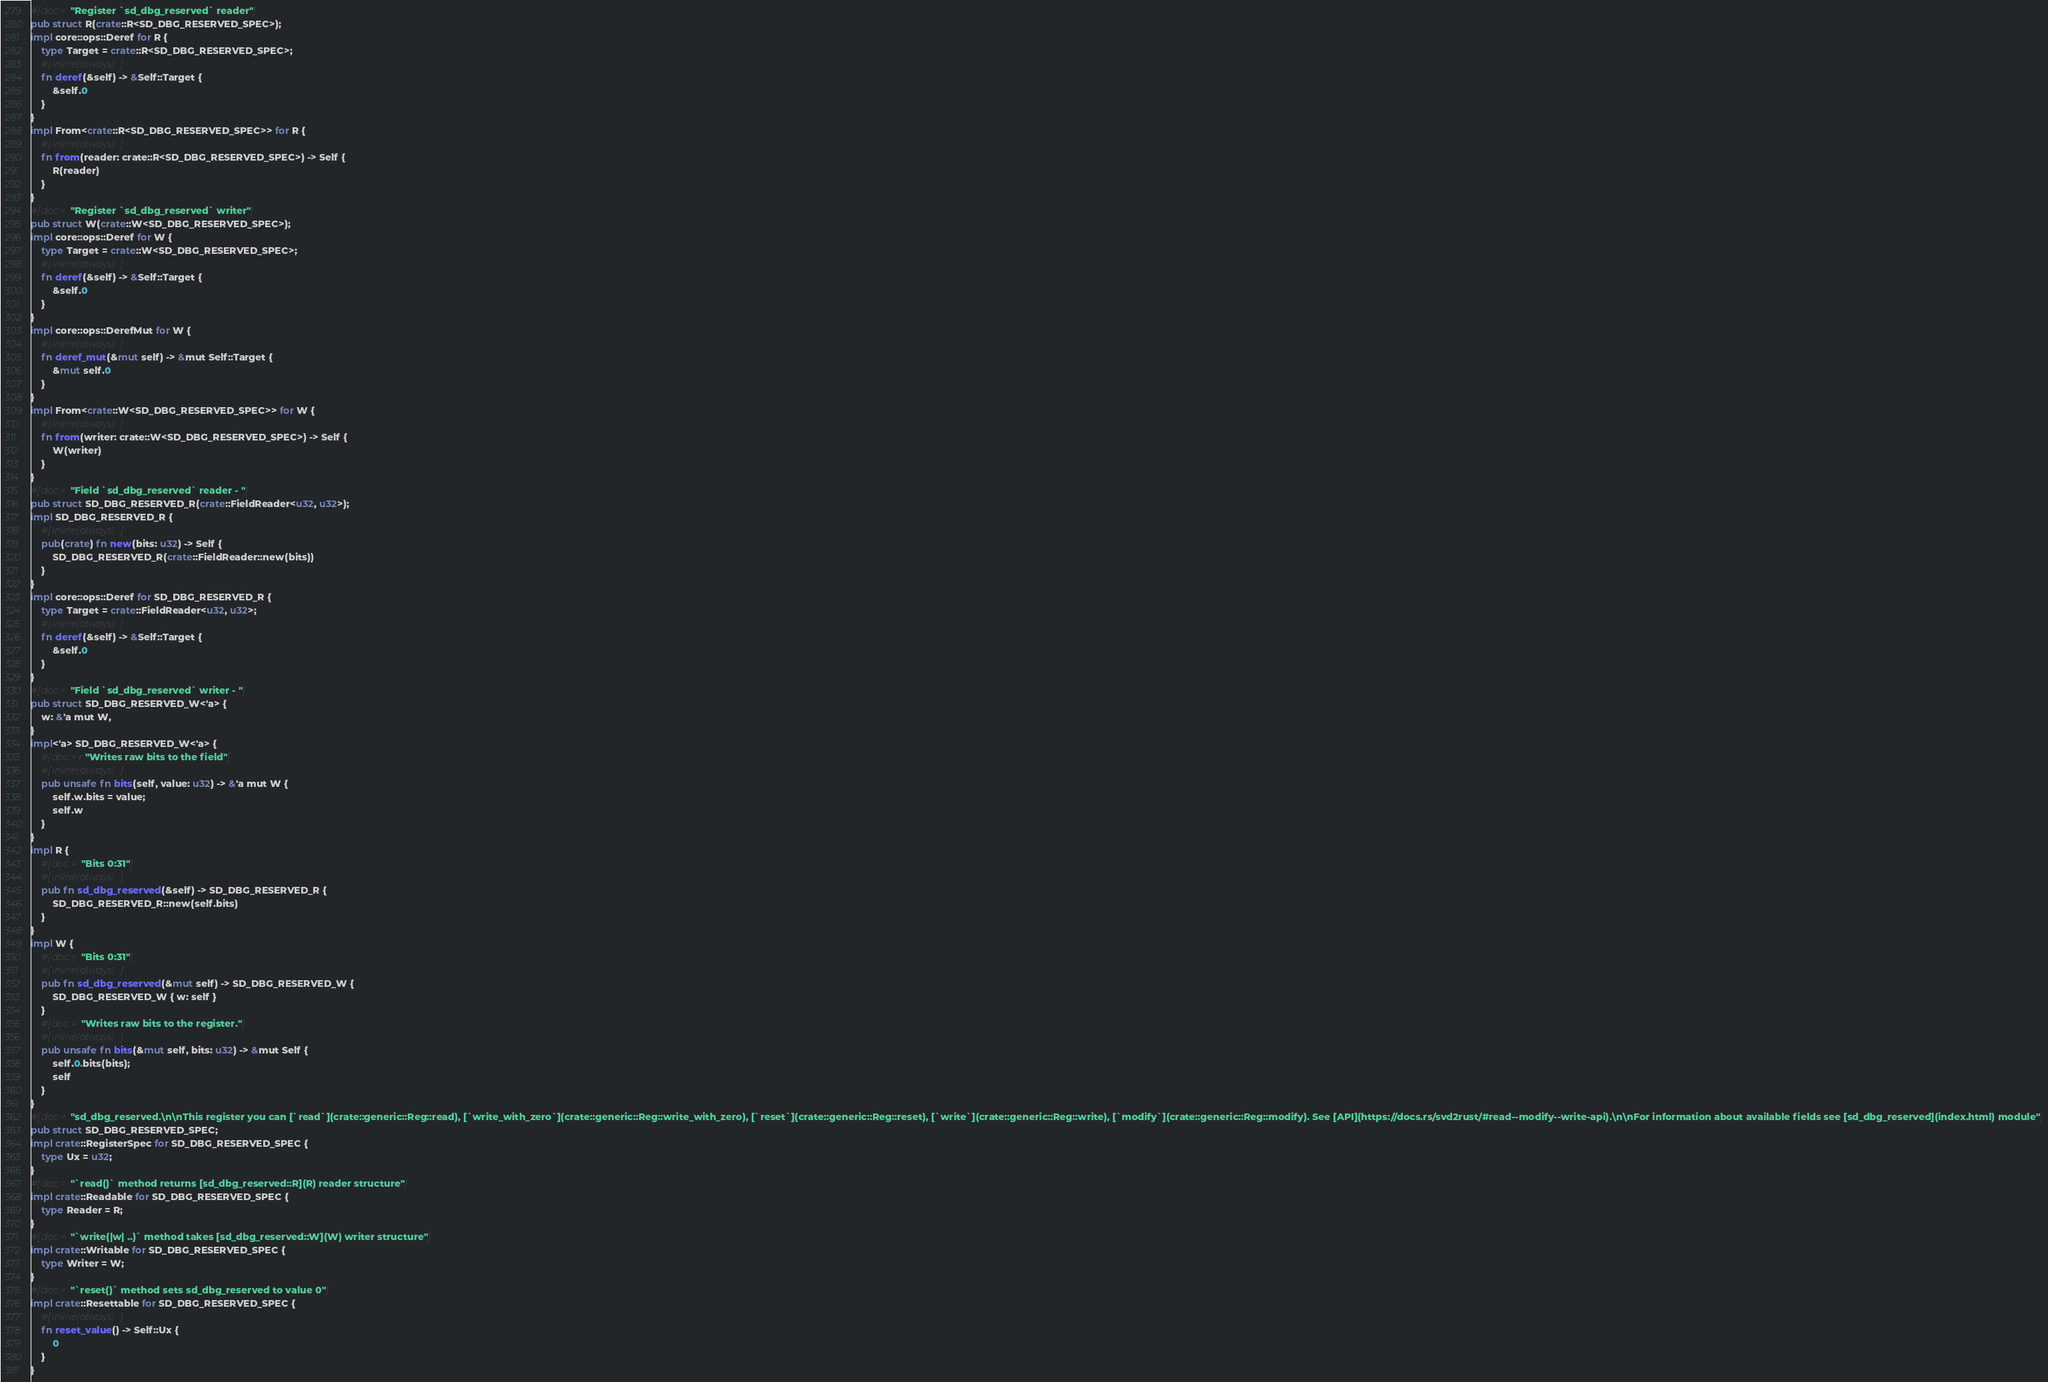<code> <loc_0><loc_0><loc_500><loc_500><_Rust_>#[doc = "Register `sd_dbg_reserved` reader"]
pub struct R(crate::R<SD_DBG_RESERVED_SPEC>);
impl core::ops::Deref for R {
    type Target = crate::R<SD_DBG_RESERVED_SPEC>;
    #[inline(always)]
    fn deref(&self) -> &Self::Target {
        &self.0
    }
}
impl From<crate::R<SD_DBG_RESERVED_SPEC>> for R {
    #[inline(always)]
    fn from(reader: crate::R<SD_DBG_RESERVED_SPEC>) -> Self {
        R(reader)
    }
}
#[doc = "Register `sd_dbg_reserved` writer"]
pub struct W(crate::W<SD_DBG_RESERVED_SPEC>);
impl core::ops::Deref for W {
    type Target = crate::W<SD_DBG_RESERVED_SPEC>;
    #[inline(always)]
    fn deref(&self) -> &Self::Target {
        &self.0
    }
}
impl core::ops::DerefMut for W {
    #[inline(always)]
    fn deref_mut(&mut self) -> &mut Self::Target {
        &mut self.0
    }
}
impl From<crate::W<SD_DBG_RESERVED_SPEC>> for W {
    #[inline(always)]
    fn from(writer: crate::W<SD_DBG_RESERVED_SPEC>) -> Self {
        W(writer)
    }
}
#[doc = "Field `sd_dbg_reserved` reader - "]
pub struct SD_DBG_RESERVED_R(crate::FieldReader<u32, u32>);
impl SD_DBG_RESERVED_R {
    #[inline(always)]
    pub(crate) fn new(bits: u32) -> Self {
        SD_DBG_RESERVED_R(crate::FieldReader::new(bits))
    }
}
impl core::ops::Deref for SD_DBG_RESERVED_R {
    type Target = crate::FieldReader<u32, u32>;
    #[inline(always)]
    fn deref(&self) -> &Self::Target {
        &self.0
    }
}
#[doc = "Field `sd_dbg_reserved` writer - "]
pub struct SD_DBG_RESERVED_W<'a> {
    w: &'a mut W,
}
impl<'a> SD_DBG_RESERVED_W<'a> {
    #[doc = r"Writes raw bits to the field"]
    #[inline(always)]
    pub unsafe fn bits(self, value: u32) -> &'a mut W {
        self.w.bits = value;
        self.w
    }
}
impl R {
    #[doc = "Bits 0:31"]
    #[inline(always)]
    pub fn sd_dbg_reserved(&self) -> SD_DBG_RESERVED_R {
        SD_DBG_RESERVED_R::new(self.bits)
    }
}
impl W {
    #[doc = "Bits 0:31"]
    #[inline(always)]
    pub fn sd_dbg_reserved(&mut self) -> SD_DBG_RESERVED_W {
        SD_DBG_RESERVED_W { w: self }
    }
    #[doc = "Writes raw bits to the register."]
    #[inline(always)]
    pub unsafe fn bits(&mut self, bits: u32) -> &mut Self {
        self.0.bits(bits);
        self
    }
}
#[doc = "sd_dbg_reserved.\n\nThis register you can [`read`](crate::generic::Reg::read), [`write_with_zero`](crate::generic::Reg::write_with_zero), [`reset`](crate::generic::Reg::reset), [`write`](crate::generic::Reg::write), [`modify`](crate::generic::Reg::modify). See [API](https://docs.rs/svd2rust/#read--modify--write-api).\n\nFor information about available fields see [sd_dbg_reserved](index.html) module"]
pub struct SD_DBG_RESERVED_SPEC;
impl crate::RegisterSpec for SD_DBG_RESERVED_SPEC {
    type Ux = u32;
}
#[doc = "`read()` method returns [sd_dbg_reserved::R](R) reader structure"]
impl crate::Readable for SD_DBG_RESERVED_SPEC {
    type Reader = R;
}
#[doc = "`write(|w| ..)` method takes [sd_dbg_reserved::W](W) writer structure"]
impl crate::Writable for SD_DBG_RESERVED_SPEC {
    type Writer = W;
}
#[doc = "`reset()` method sets sd_dbg_reserved to value 0"]
impl crate::Resettable for SD_DBG_RESERVED_SPEC {
    #[inline(always)]
    fn reset_value() -> Self::Ux {
        0
    }
}
</code> 